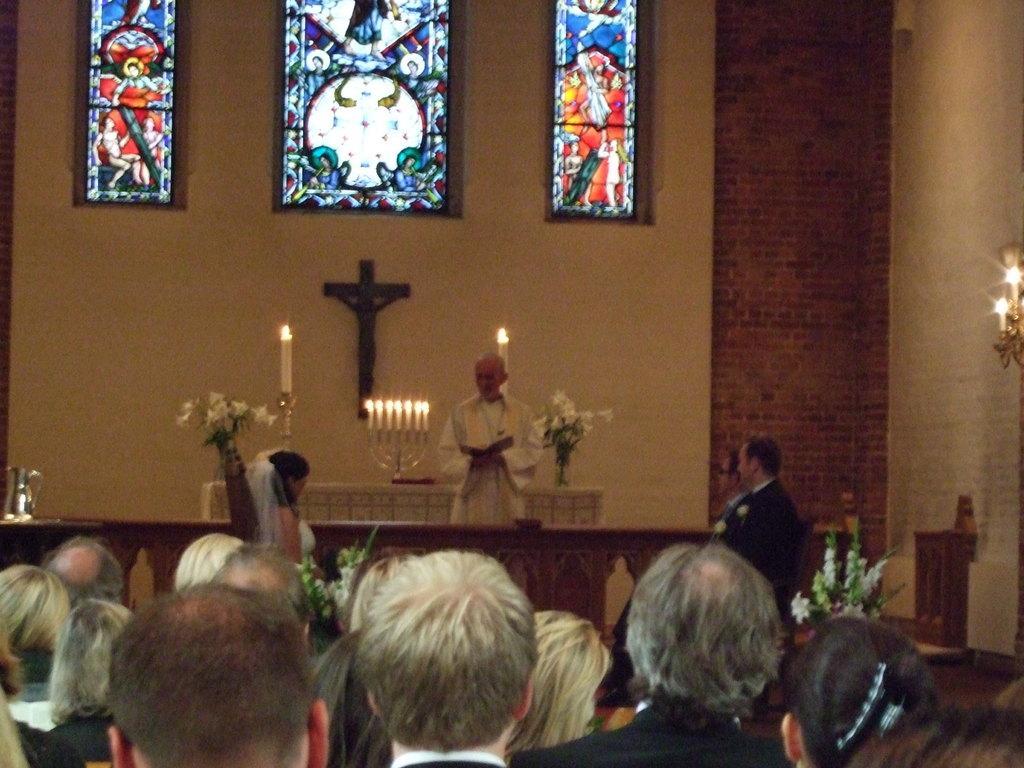Please provide a concise description of this image. This image is taken from inside the church. In this image there are a few people, in front of them there are a few people standing, one of them is holding a book, behind him there is like a platform on which there are two flower pots and candle, there is a cross attached to the wall and there are a few windows with some paintings. On the left side of the image there is a jar, on the right side of the image there is a candle stand hanging on the wall. 